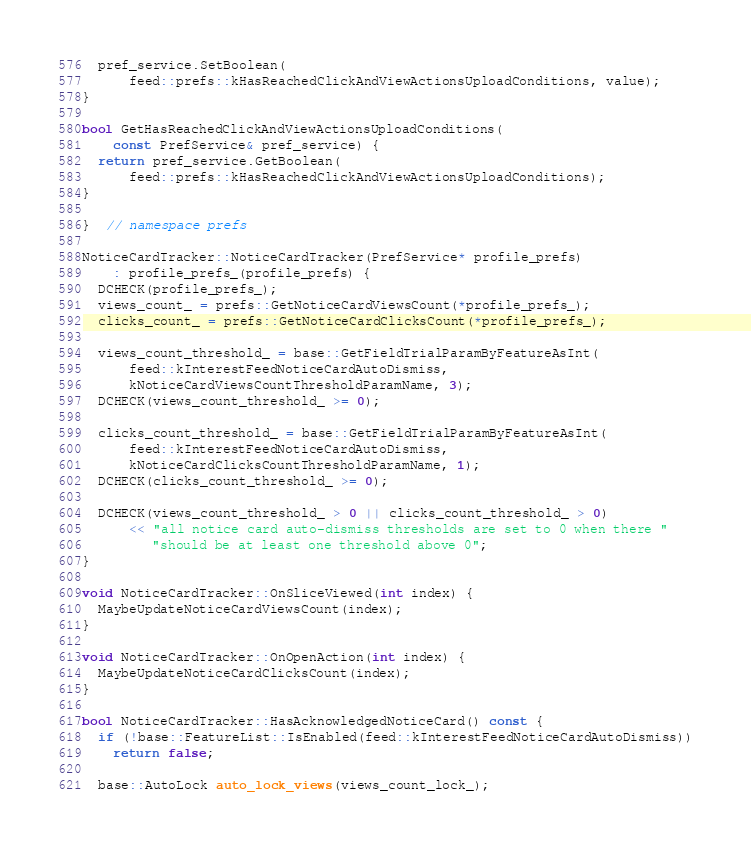<code> <loc_0><loc_0><loc_500><loc_500><_C++_>  pref_service.SetBoolean(
      feed::prefs::kHasReachedClickAndViewActionsUploadConditions, value);
}

bool GetHasReachedClickAndViewActionsUploadConditions(
    const PrefService& pref_service) {
  return pref_service.GetBoolean(
      feed::prefs::kHasReachedClickAndViewActionsUploadConditions);
}

}  // namespace prefs

NoticeCardTracker::NoticeCardTracker(PrefService* profile_prefs)
    : profile_prefs_(profile_prefs) {
  DCHECK(profile_prefs_);
  views_count_ = prefs::GetNoticeCardViewsCount(*profile_prefs_);
  clicks_count_ = prefs::GetNoticeCardClicksCount(*profile_prefs_);

  views_count_threshold_ = base::GetFieldTrialParamByFeatureAsInt(
      feed::kInterestFeedNoticeCardAutoDismiss,
      kNoticeCardViewsCountThresholdParamName, 3);
  DCHECK(views_count_threshold_ >= 0);

  clicks_count_threshold_ = base::GetFieldTrialParamByFeatureAsInt(
      feed::kInterestFeedNoticeCardAutoDismiss,
      kNoticeCardClicksCountThresholdParamName, 1);
  DCHECK(clicks_count_threshold_ >= 0);

  DCHECK(views_count_threshold_ > 0 || clicks_count_threshold_ > 0)
      << "all notice card auto-dismiss thresholds are set to 0 when there "
         "should be at least one threshold above 0";
}

void NoticeCardTracker::OnSliceViewed(int index) {
  MaybeUpdateNoticeCardViewsCount(index);
}

void NoticeCardTracker::OnOpenAction(int index) {
  MaybeUpdateNoticeCardClicksCount(index);
}

bool NoticeCardTracker::HasAcknowledgedNoticeCard() const {
  if (!base::FeatureList::IsEnabled(feed::kInterestFeedNoticeCardAutoDismiss))
    return false;

  base::AutoLock auto_lock_views(views_count_lock_);</code> 